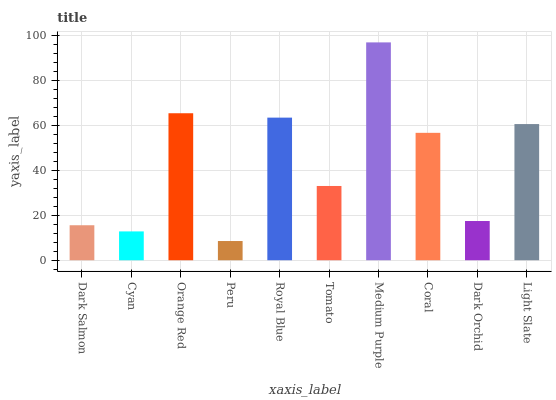Is Cyan the minimum?
Answer yes or no. No. Is Cyan the maximum?
Answer yes or no. No. Is Dark Salmon greater than Cyan?
Answer yes or no. Yes. Is Cyan less than Dark Salmon?
Answer yes or no. Yes. Is Cyan greater than Dark Salmon?
Answer yes or no. No. Is Dark Salmon less than Cyan?
Answer yes or no. No. Is Coral the high median?
Answer yes or no. Yes. Is Tomato the low median?
Answer yes or no. Yes. Is Medium Purple the high median?
Answer yes or no. No. Is Medium Purple the low median?
Answer yes or no. No. 